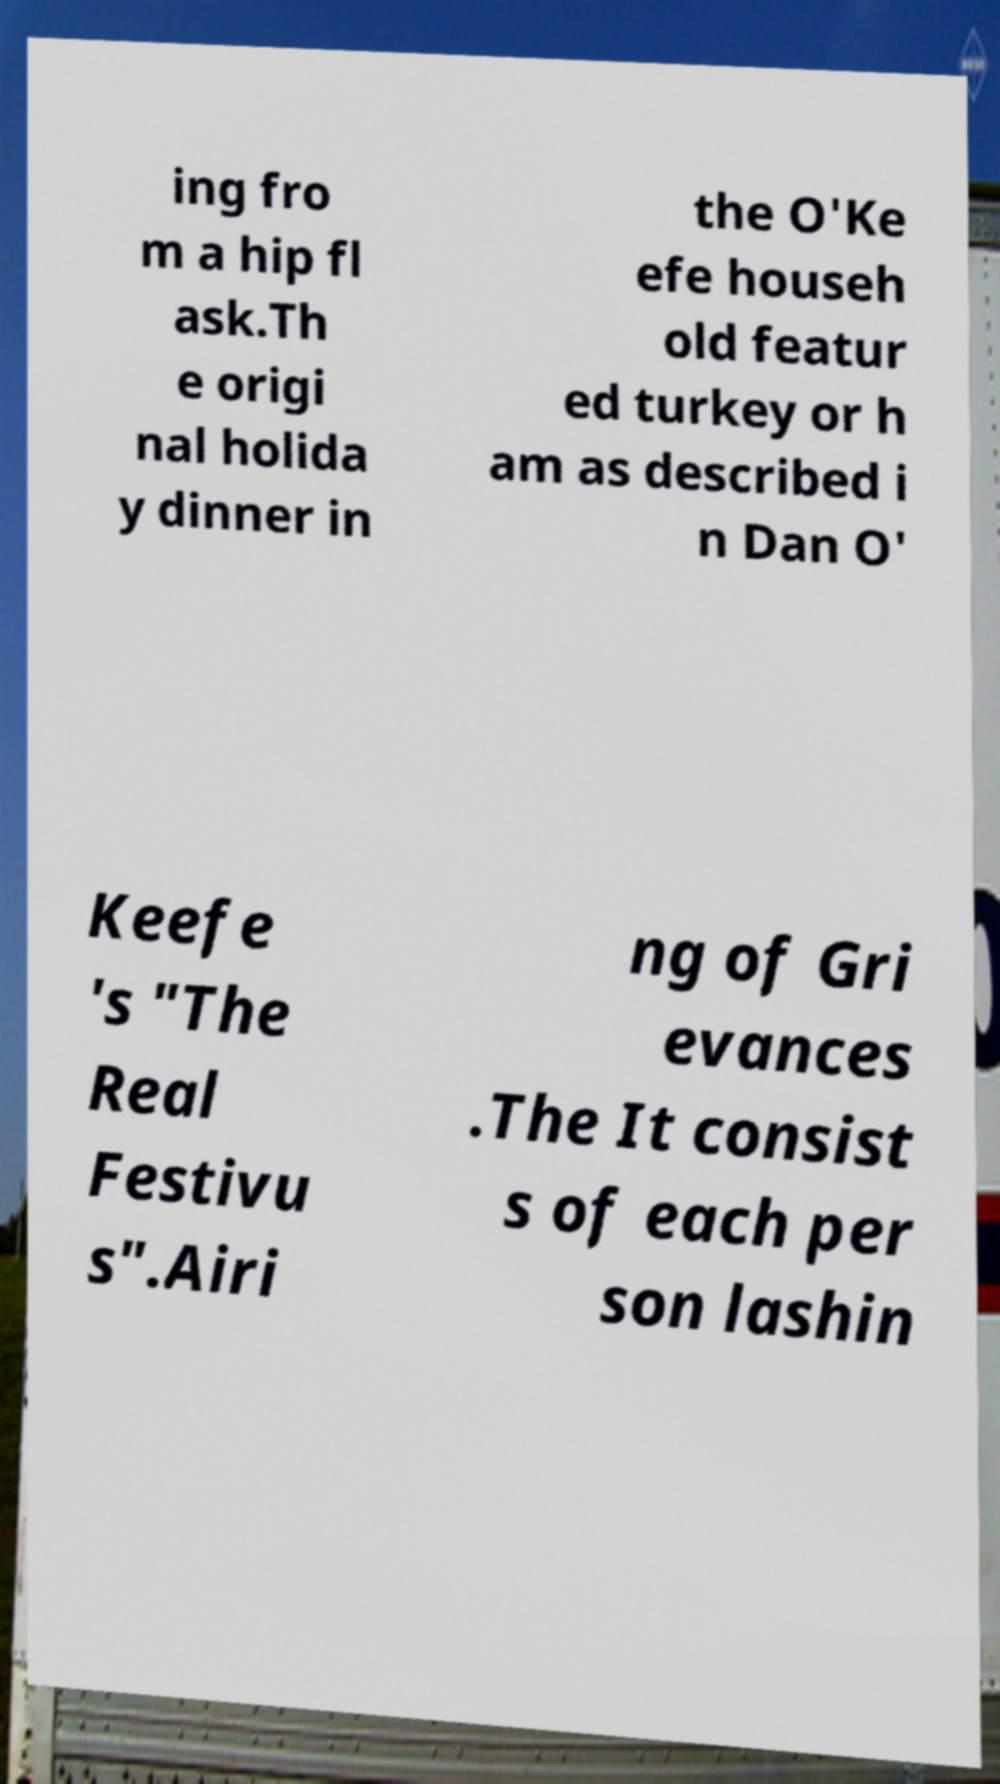Can you accurately transcribe the text from the provided image for me? ing fro m a hip fl ask.Th e origi nal holida y dinner in the O'Ke efe househ old featur ed turkey or h am as described i n Dan O' Keefe 's "The Real Festivu s".Airi ng of Gri evances .The It consist s of each per son lashin 